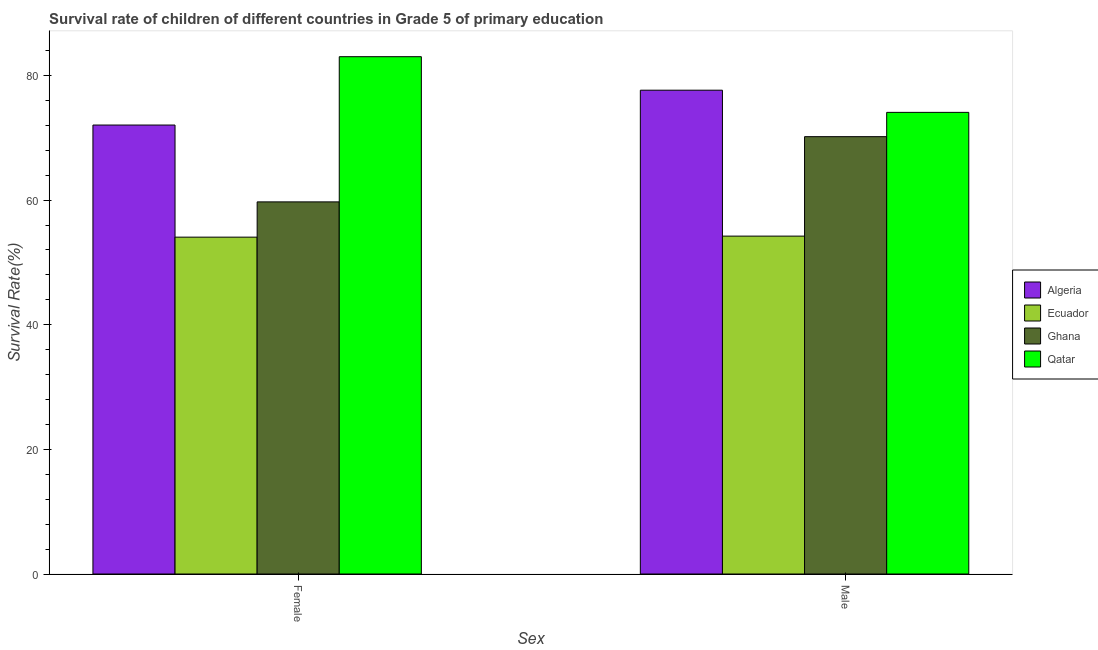How many different coloured bars are there?
Offer a very short reply. 4. Are the number of bars per tick equal to the number of legend labels?
Your answer should be compact. Yes. What is the survival rate of male students in primary education in Algeria?
Provide a succinct answer. 77.64. Across all countries, what is the maximum survival rate of male students in primary education?
Give a very brief answer. 77.64. Across all countries, what is the minimum survival rate of female students in primary education?
Ensure brevity in your answer.  54.06. In which country was the survival rate of male students in primary education maximum?
Offer a terse response. Algeria. In which country was the survival rate of female students in primary education minimum?
Your answer should be very brief. Ecuador. What is the total survival rate of male students in primary education in the graph?
Give a very brief answer. 276.14. What is the difference between the survival rate of female students in primary education in Algeria and that in Ghana?
Give a very brief answer. 12.33. What is the difference between the survival rate of male students in primary education in Ecuador and the survival rate of female students in primary education in Qatar?
Provide a short and direct response. -28.79. What is the average survival rate of female students in primary education per country?
Offer a terse response. 67.21. What is the difference between the survival rate of female students in primary education and survival rate of male students in primary education in Ecuador?
Keep it short and to the point. -0.17. What is the ratio of the survival rate of female students in primary education in Ghana to that in Algeria?
Give a very brief answer. 0.83. Is the survival rate of male students in primary education in Qatar less than that in Ghana?
Provide a succinct answer. No. In how many countries, is the survival rate of female students in primary education greater than the average survival rate of female students in primary education taken over all countries?
Offer a terse response. 2. What does the 3rd bar from the left in Female represents?
Your answer should be very brief. Ghana. How many countries are there in the graph?
Offer a terse response. 4. Where does the legend appear in the graph?
Offer a very short reply. Center right. How many legend labels are there?
Your answer should be compact. 4. What is the title of the graph?
Provide a succinct answer. Survival rate of children of different countries in Grade 5 of primary education. Does "Palau" appear as one of the legend labels in the graph?
Give a very brief answer. No. What is the label or title of the X-axis?
Offer a terse response. Sex. What is the label or title of the Y-axis?
Your answer should be very brief. Survival Rate(%). What is the Survival Rate(%) in Algeria in Female?
Ensure brevity in your answer.  72.05. What is the Survival Rate(%) in Ecuador in Female?
Your answer should be compact. 54.06. What is the Survival Rate(%) of Ghana in Female?
Your answer should be compact. 59.72. What is the Survival Rate(%) in Qatar in Female?
Offer a very short reply. 83.02. What is the Survival Rate(%) of Algeria in Male?
Give a very brief answer. 77.64. What is the Survival Rate(%) in Ecuador in Male?
Give a very brief answer. 54.23. What is the Survival Rate(%) in Ghana in Male?
Give a very brief answer. 70.19. What is the Survival Rate(%) in Qatar in Male?
Provide a succinct answer. 74.08. Across all Sex, what is the maximum Survival Rate(%) in Algeria?
Your response must be concise. 77.64. Across all Sex, what is the maximum Survival Rate(%) of Ecuador?
Your response must be concise. 54.23. Across all Sex, what is the maximum Survival Rate(%) in Ghana?
Offer a terse response. 70.19. Across all Sex, what is the maximum Survival Rate(%) of Qatar?
Provide a succinct answer. 83.02. Across all Sex, what is the minimum Survival Rate(%) in Algeria?
Give a very brief answer. 72.05. Across all Sex, what is the minimum Survival Rate(%) in Ecuador?
Provide a short and direct response. 54.06. Across all Sex, what is the minimum Survival Rate(%) in Ghana?
Provide a succinct answer. 59.72. Across all Sex, what is the minimum Survival Rate(%) of Qatar?
Provide a short and direct response. 74.08. What is the total Survival Rate(%) of Algeria in the graph?
Keep it short and to the point. 149.69. What is the total Survival Rate(%) in Ecuador in the graph?
Keep it short and to the point. 108.28. What is the total Survival Rate(%) in Ghana in the graph?
Provide a succinct answer. 129.91. What is the total Survival Rate(%) in Qatar in the graph?
Give a very brief answer. 157.1. What is the difference between the Survival Rate(%) in Algeria in Female and that in Male?
Provide a succinct answer. -5.59. What is the difference between the Survival Rate(%) of Ecuador in Female and that in Male?
Ensure brevity in your answer.  -0.17. What is the difference between the Survival Rate(%) in Ghana in Female and that in Male?
Your answer should be very brief. -10.47. What is the difference between the Survival Rate(%) in Qatar in Female and that in Male?
Keep it short and to the point. 8.94. What is the difference between the Survival Rate(%) of Algeria in Female and the Survival Rate(%) of Ecuador in Male?
Ensure brevity in your answer.  17.82. What is the difference between the Survival Rate(%) of Algeria in Female and the Survival Rate(%) of Ghana in Male?
Ensure brevity in your answer.  1.86. What is the difference between the Survival Rate(%) in Algeria in Female and the Survival Rate(%) in Qatar in Male?
Offer a very short reply. -2.03. What is the difference between the Survival Rate(%) of Ecuador in Female and the Survival Rate(%) of Ghana in Male?
Provide a succinct answer. -16.13. What is the difference between the Survival Rate(%) of Ecuador in Female and the Survival Rate(%) of Qatar in Male?
Your answer should be compact. -20.03. What is the difference between the Survival Rate(%) in Ghana in Female and the Survival Rate(%) in Qatar in Male?
Give a very brief answer. -14.37. What is the average Survival Rate(%) of Algeria per Sex?
Provide a succinct answer. 74.85. What is the average Survival Rate(%) of Ecuador per Sex?
Your answer should be very brief. 54.14. What is the average Survival Rate(%) in Ghana per Sex?
Offer a terse response. 64.95. What is the average Survival Rate(%) in Qatar per Sex?
Provide a succinct answer. 78.55. What is the difference between the Survival Rate(%) in Algeria and Survival Rate(%) in Ecuador in Female?
Your response must be concise. 17.99. What is the difference between the Survival Rate(%) in Algeria and Survival Rate(%) in Ghana in Female?
Provide a succinct answer. 12.33. What is the difference between the Survival Rate(%) in Algeria and Survival Rate(%) in Qatar in Female?
Provide a succinct answer. -10.97. What is the difference between the Survival Rate(%) in Ecuador and Survival Rate(%) in Ghana in Female?
Offer a terse response. -5.66. What is the difference between the Survival Rate(%) in Ecuador and Survival Rate(%) in Qatar in Female?
Offer a very short reply. -28.96. What is the difference between the Survival Rate(%) in Ghana and Survival Rate(%) in Qatar in Female?
Your response must be concise. -23.3. What is the difference between the Survival Rate(%) in Algeria and Survival Rate(%) in Ecuador in Male?
Your answer should be compact. 23.42. What is the difference between the Survival Rate(%) in Algeria and Survival Rate(%) in Ghana in Male?
Offer a very short reply. 7.46. What is the difference between the Survival Rate(%) of Algeria and Survival Rate(%) of Qatar in Male?
Make the answer very short. 3.56. What is the difference between the Survival Rate(%) of Ecuador and Survival Rate(%) of Ghana in Male?
Provide a short and direct response. -15.96. What is the difference between the Survival Rate(%) in Ecuador and Survival Rate(%) in Qatar in Male?
Give a very brief answer. -19.86. What is the difference between the Survival Rate(%) in Ghana and Survival Rate(%) in Qatar in Male?
Give a very brief answer. -3.9. What is the ratio of the Survival Rate(%) of Algeria in Female to that in Male?
Offer a very short reply. 0.93. What is the ratio of the Survival Rate(%) of Ghana in Female to that in Male?
Your response must be concise. 0.85. What is the ratio of the Survival Rate(%) in Qatar in Female to that in Male?
Your response must be concise. 1.12. What is the difference between the highest and the second highest Survival Rate(%) in Algeria?
Offer a very short reply. 5.59. What is the difference between the highest and the second highest Survival Rate(%) in Ecuador?
Make the answer very short. 0.17. What is the difference between the highest and the second highest Survival Rate(%) in Ghana?
Give a very brief answer. 10.47. What is the difference between the highest and the second highest Survival Rate(%) of Qatar?
Offer a terse response. 8.94. What is the difference between the highest and the lowest Survival Rate(%) in Algeria?
Give a very brief answer. 5.59. What is the difference between the highest and the lowest Survival Rate(%) in Ecuador?
Offer a very short reply. 0.17. What is the difference between the highest and the lowest Survival Rate(%) of Ghana?
Keep it short and to the point. 10.47. What is the difference between the highest and the lowest Survival Rate(%) of Qatar?
Keep it short and to the point. 8.94. 